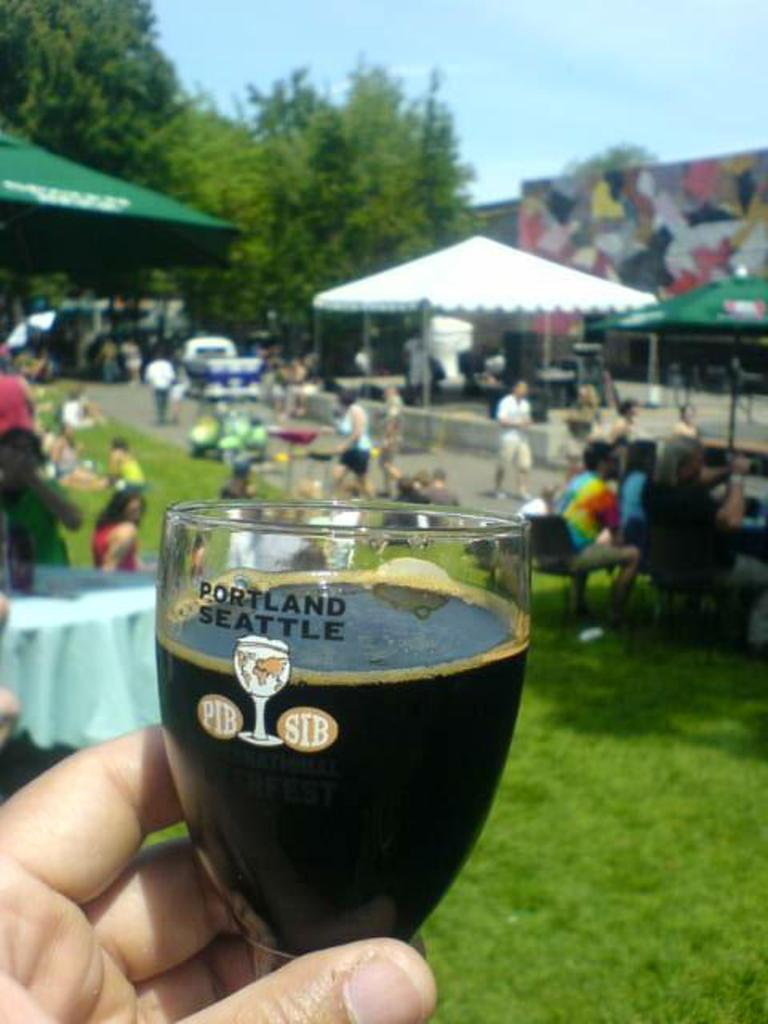<image>
Provide a brief description of the given image. A person is holding a glass that says, 'Portland Seattle', at an outdoor festival. 